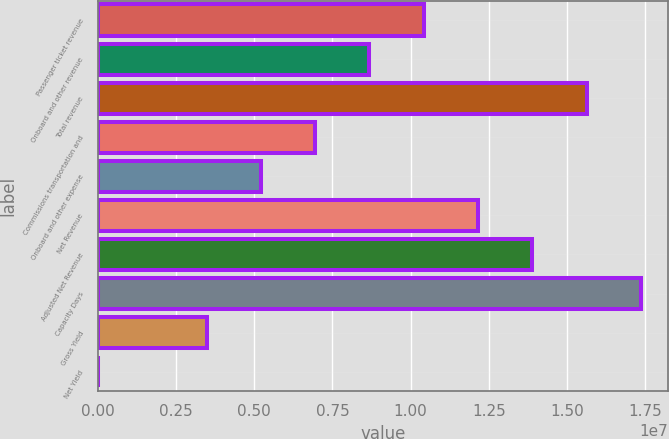<chart> <loc_0><loc_0><loc_500><loc_500><bar_chart><fcel>Passenger ticket revenue<fcel>Onboard and other revenue<fcel>Total revenue<fcel>Commissions transportation and<fcel>Onboard and other expense<fcel>Net Revenue<fcel>Adjusted Net Revenue<fcel>Capacity Days<fcel>Gross Yield<fcel>Net Yield<nl><fcel>1.04181e+07<fcel>8.68183e+06<fcel>1.56271e+07<fcel>6.94551e+06<fcel>5.2092e+06<fcel>1.21545e+07<fcel>1.38908e+07<fcel>1.73634e+07<fcel>3.47288e+06<fcel>241.36<nl></chart> 